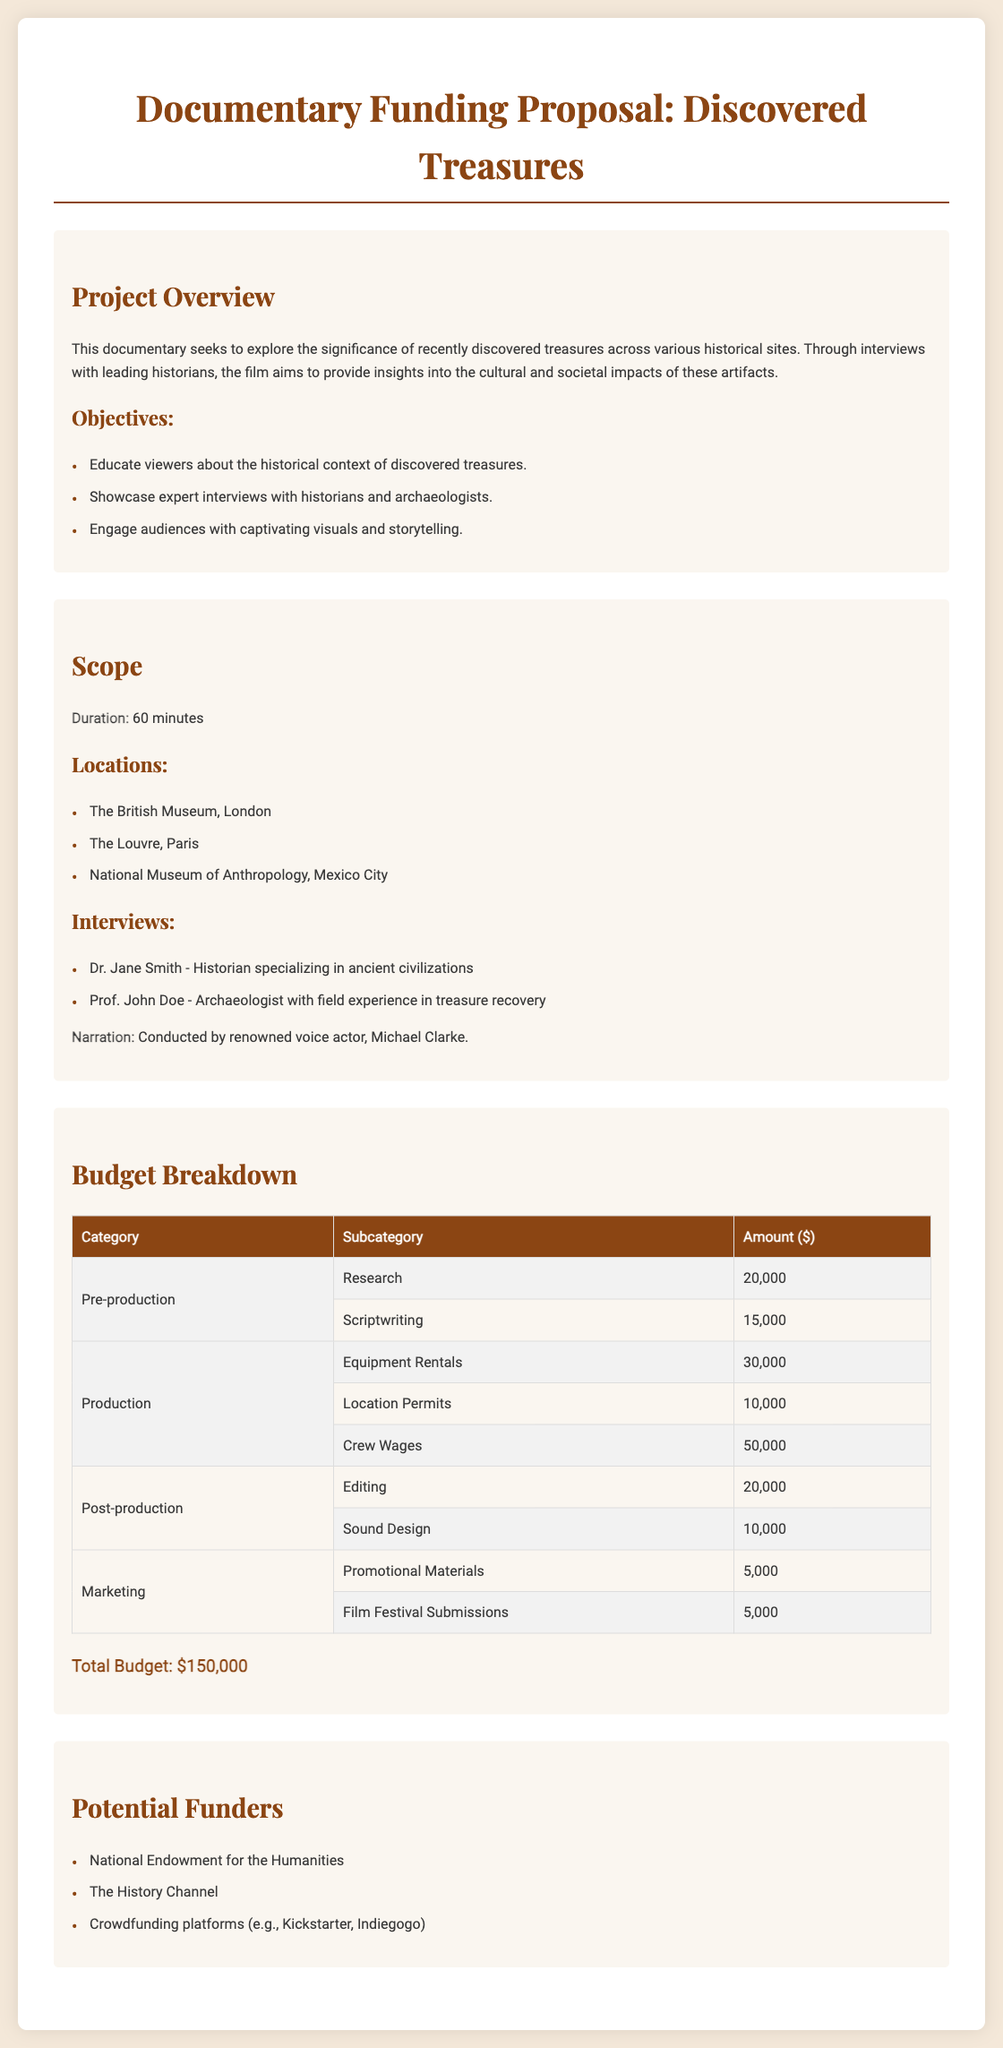What is the project duration? The project duration is specified in the scope section of the document as 60 minutes.
Answer: 60 minutes Who is the narrator of the documentary? The narration is conducted by renowned voice actor, Michael Clarke, as stated in the scope section.
Answer: Michael Clarke What is the total budget for the documentary? The total budget is featured in the budget breakdown as the sum of all budget categories, amounting to $150,000.
Answer: $150,000 Which museum is located in Paris? The Louvre is mentioned as one of the locations in the scope section of the document.
Answer: The Louvre How much is allocated for crew wages? The amount for crew wages is found in the budget breakdown under the production category, which is $50,000.
Answer: $50,000 What are the two categories of expenses in the budget? The budget breakdown includes categories such as Pre-production, Production, Post-production, and Marketing. The question specifically asks for two categories, any two can be taken: Pre-production and Production.
Answer: Pre-production, Production What is the amount allocated for research? The allocated amount for research is stated in the budget breakdown under the pre-production category as $20,000.
Answer: $20,000 Which historical figure is interviewed in the documentary? Dr. Jane Smith is mentioned in the scope section as one of the historians interviewed in the documentary.
Answer: Dr. Jane Smith How many locations are specified for the documentary? The number of locations is specified in the scope section and counts as three.
Answer: Three 